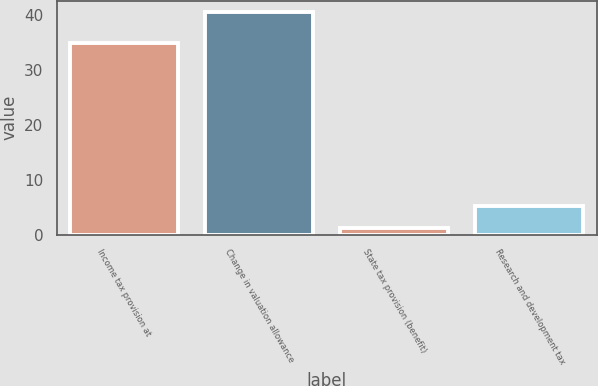Convert chart. <chart><loc_0><loc_0><loc_500><loc_500><bar_chart><fcel>Income tax provision at<fcel>Change in valuation allowance<fcel>State tax provision (benefit)<fcel>Research and development tax<nl><fcel>35<fcel>40.6<fcel>1.2<fcel>5.14<nl></chart> 